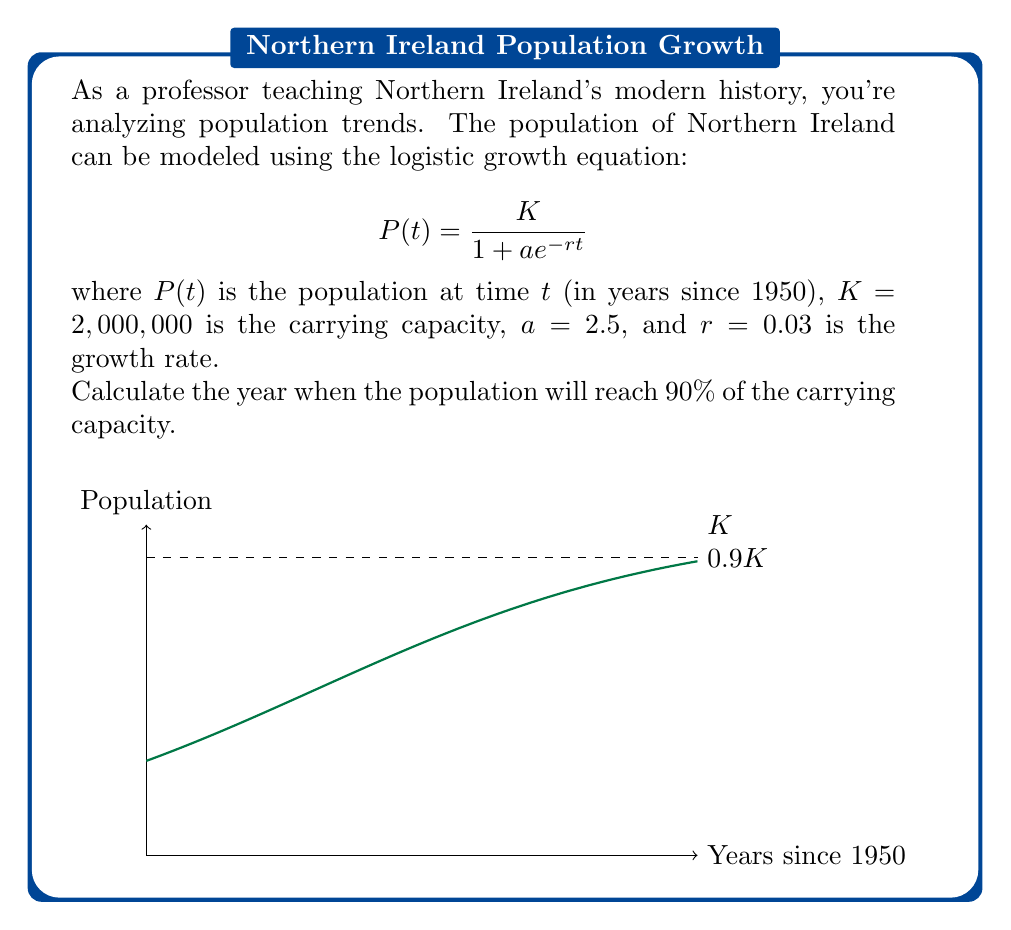Can you solve this math problem? Let's approach this step-by-step:

1) We want to find $t$ when $P(t) = 0.9K = 0.9 \times 2,000,000 = 1,800,000$

2) Substitute this into the logistic growth equation:

   $$1,800,000 = \frac{2,000,000}{1 + 2.5e^{-0.03t}}$$

3) Simplify:
   $$0.9 = \frac{1}{1 + 2.5e^{-0.03t}}$$

4) Take the reciprocal of both sides:
   $$\frac{10}{9} = 1 + 2.5e^{-0.03t}$$

5) Subtract 1 from both sides:
   $$\frac{1}{9} = 2.5e^{-0.03t}$$

6) Divide both sides by 2.5:
   $$\frac{1}{22.5} = e^{-0.03t}$$

7) Take the natural log of both sides:
   $$\ln(\frac{1}{22.5}) = -0.03t$$

8) Divide both sides by -0.03:
   $$\frac{\ln(22.5)}{0.03} = t$$

9) Calculate:
   $$t \approx 103.97$$

10) Since $t$ is years since 1950, add 1950 to get the actual year:
    $1950 + 103.97 \approx 2054$
Answer: 2054 